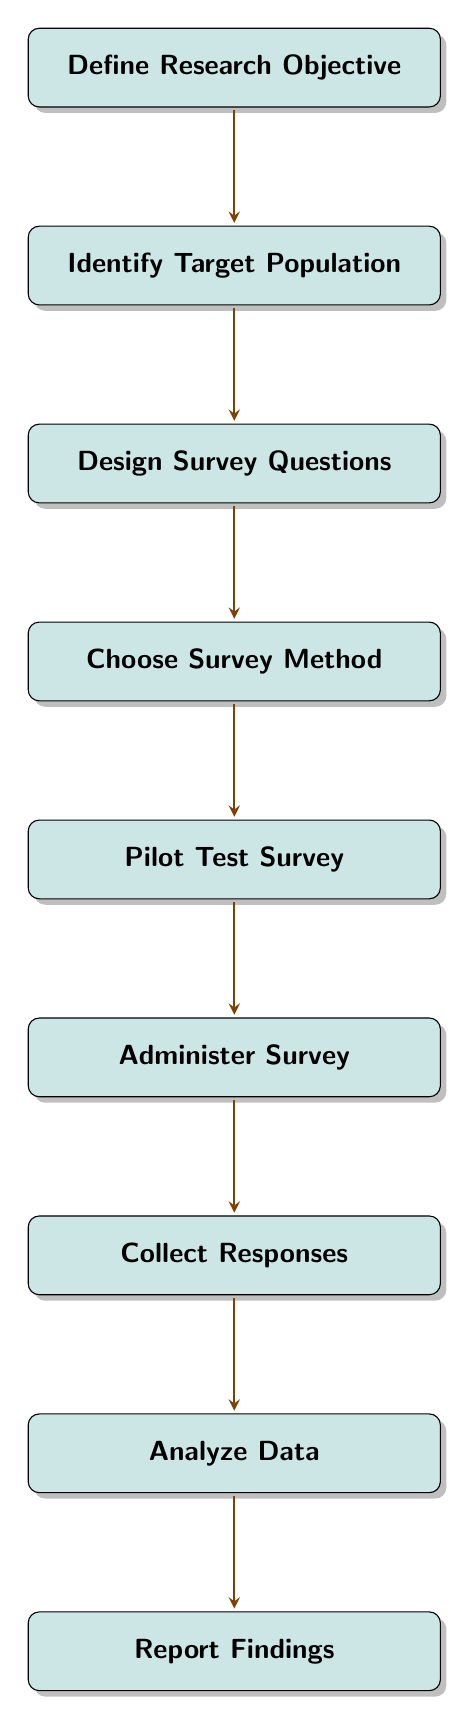What is the first step in designing a survey? The first step is clearly defined as "Define Research Objective," which articulates the research goals and objectives. This is explicitly shown as the top node in the flow chart.
Answer: Define Research Objective How many nodes are present in the diagram? The diagram has nine distinct nodes, each representing a step in the survey design process, which can be counted directly from the visual representation.
Answer: Nine Which node comes after "Pilot Test Survey"? The node that follows "Pilot Test Survey" is "Administer Survey," indicating the next action to take in the flow of steps. This is observed by moving down the chart from "Pilot Test Survey."
Answer: Administer Survey What is the last step in the survey design process? The final step indicated in the flow chart is "Report Findings," which is the last node at the bottom of the diagram.
Answer: Report Findings Which two nodes are directly connected by an arrow following the "Design Survey Questions"? After "Design Survey Questions," the next connected node, as indicated by the arrow pointing downwards, is "Choose Survey Method." This shows a clear sequential flow from designing questions to selecting the survey method.
Answer: Choose Survey Method What is the relationship between "Collect Responses" and "Analyze Data"? "Collect Responses" is immediately before "Analyze Data," suggesting that the collection of survey responses directly precedes the analysis of the data gathered. This is evident from the order of the nodes shown in the diagram.
Answer: Sequential What action should be taken after "Administer Survey"? Following "Administer Survey," the action that should be taken is to "Collect Responses." This is a direct continuation in the flow of the survey process as visualized in the diagram.
Answer: Collect Responses Which step focuses on identifying issues before full distribution? The step that focuses on identifying issues in the survey before it is widely distributed is "Pilot Test Survey." This is highlighted as a necessary step to refine the survey approach based on preliminary feedback.
Answer: Pilot Test Survey What is the primary purpose of "Analyze Data"? The primary purpose of "Analyze Data" is to interpret the responses collected from the survey, which allows researchers to draw conclusions based on the data obtained throughout the survey process.
Answer: Interpret responses 